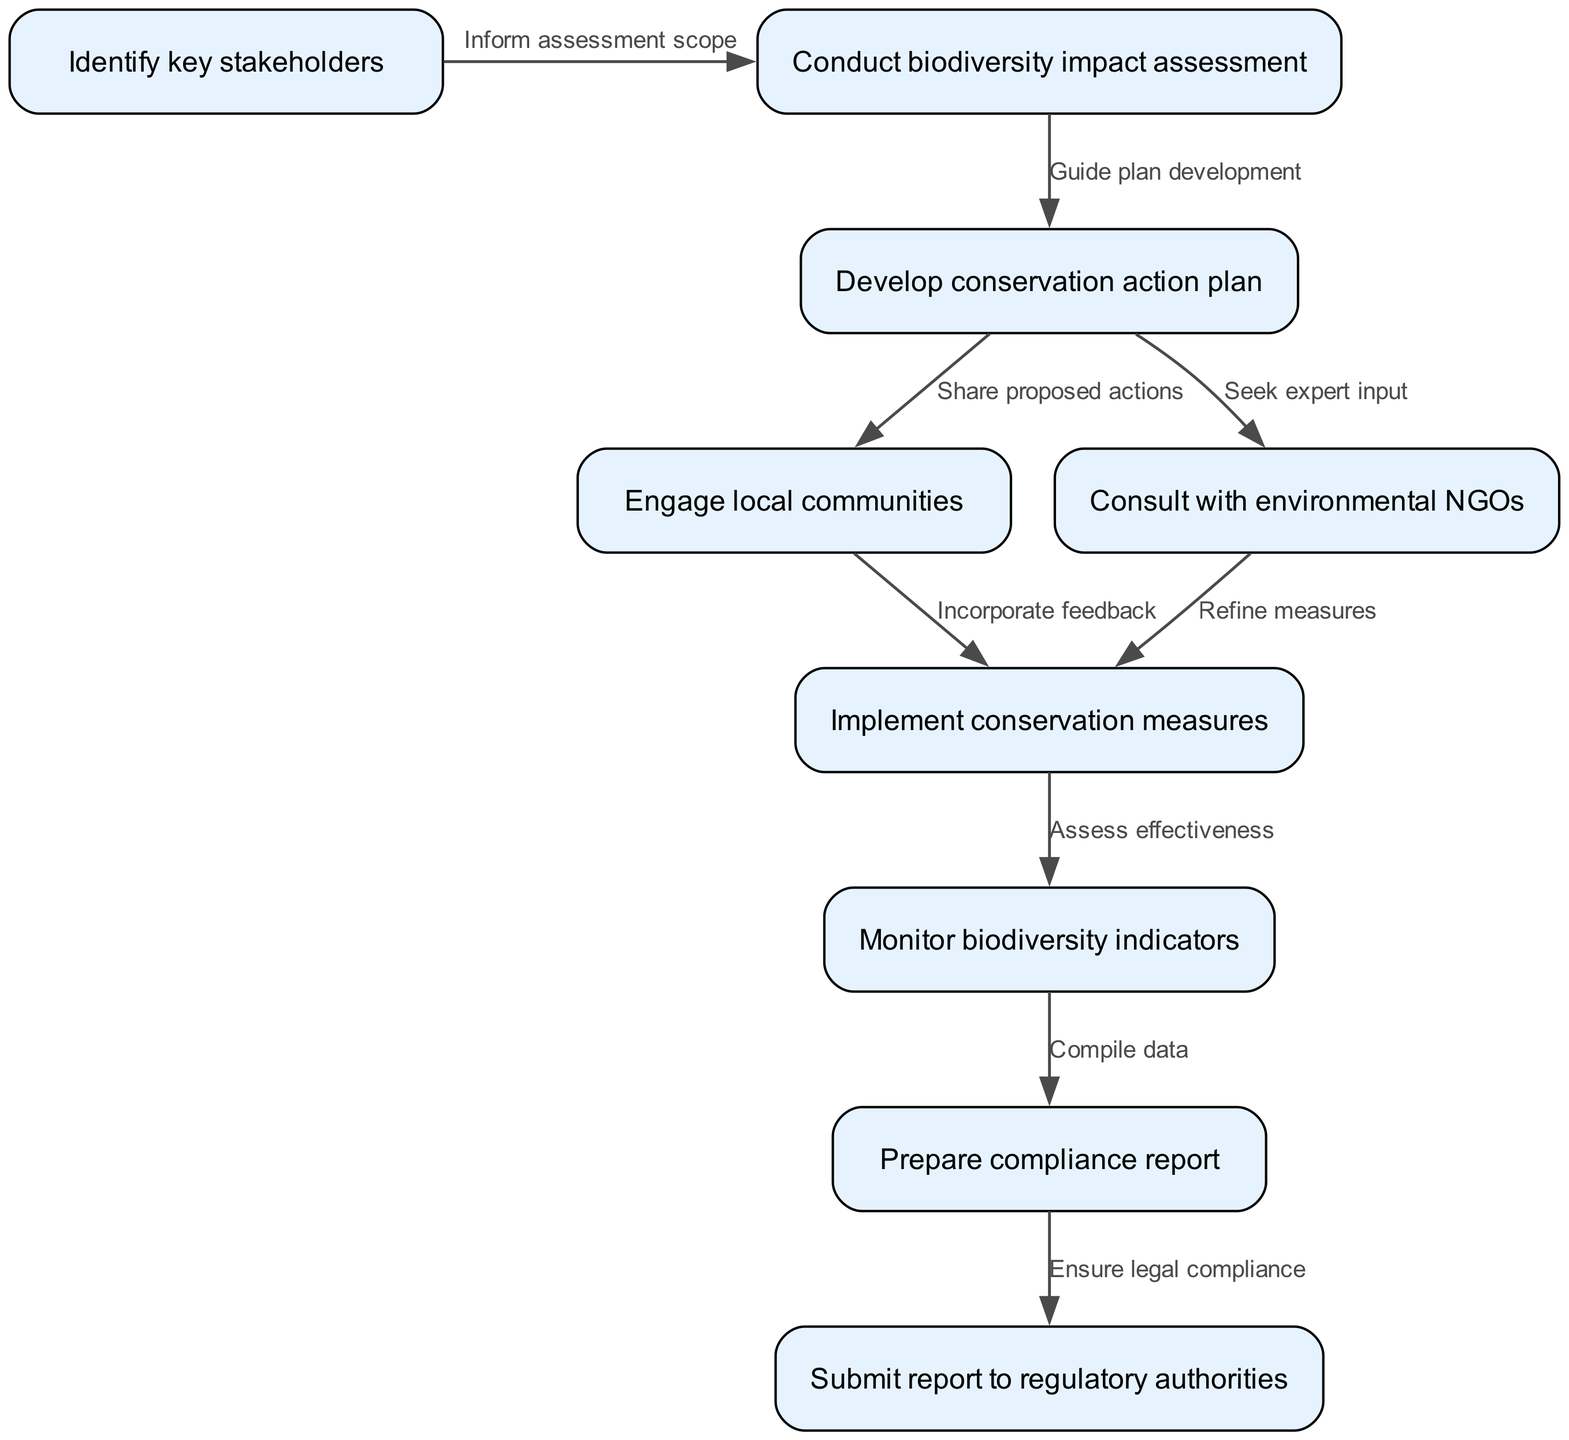What is the first step in the pathway? The first node in the diagram is labeled "Identify key stakeholders," which indicates the initial action to take in the pathway.
Answer: Identify key stakeholders How many nodes are present in the diagram? By counting the listed nodes in the provided data, there are 9 nodes depicted in the diagram, representing various stages of the pathway.
Answer: 9 What action follows the biodiversity impact assessment? The edge from node "2" identifies the next step as developing a conservation action plan, indicating this is the requisite action following the assessment.
Answer: Develop conservation action plan Which stakeholder engagement occurs before implementing conservation measures? The direct path from node "4" (Engage local communities) to node "6" (Implement conservation measures) shows that community engagement is an essential precursor to the implementation of measures.
Answer: Engage local communities How does the conservation action plan guide subsequent steps? The linkage from node "3" (Develop conservation action plan) to both node "4" (Engage local communities) and node "5" (Consult with environmental NGOs) suggests the plan informs how to engage both communities and NGOs effectively.
Answer: It informs engagement strategies What is the final step before submitting the report to regulatory authorities? The diagram indicates that the last action before submission is to prepare a compliance report, as reflected by the edge connecting nodes "8" and "9."
Answer: Prepare compliance report What is the relationship between monitoring biodiversity indicators and preparing a compliance report? The pathway from node "7" (Monitor biodiversity indicators) to node "8" (Prepare compliance report) shows that monitoring is essential for compiling the necessary data for the compliance report, establishing a direct dependency.
Answer: Monitoring is essential for compliance How many edges are there connecting the nodes? The data indicates a total of 8 edges representing the relationships and pathways between the nodes, which outlines the flow of the process.
Answer: 8 What is the purpose of consulting with environmental NGOs? Following node "5," the purpose is indicated as seeking expert input to refine conservation measures, which is an essential component for effective conservation planning.
Answer: Seek expert input 